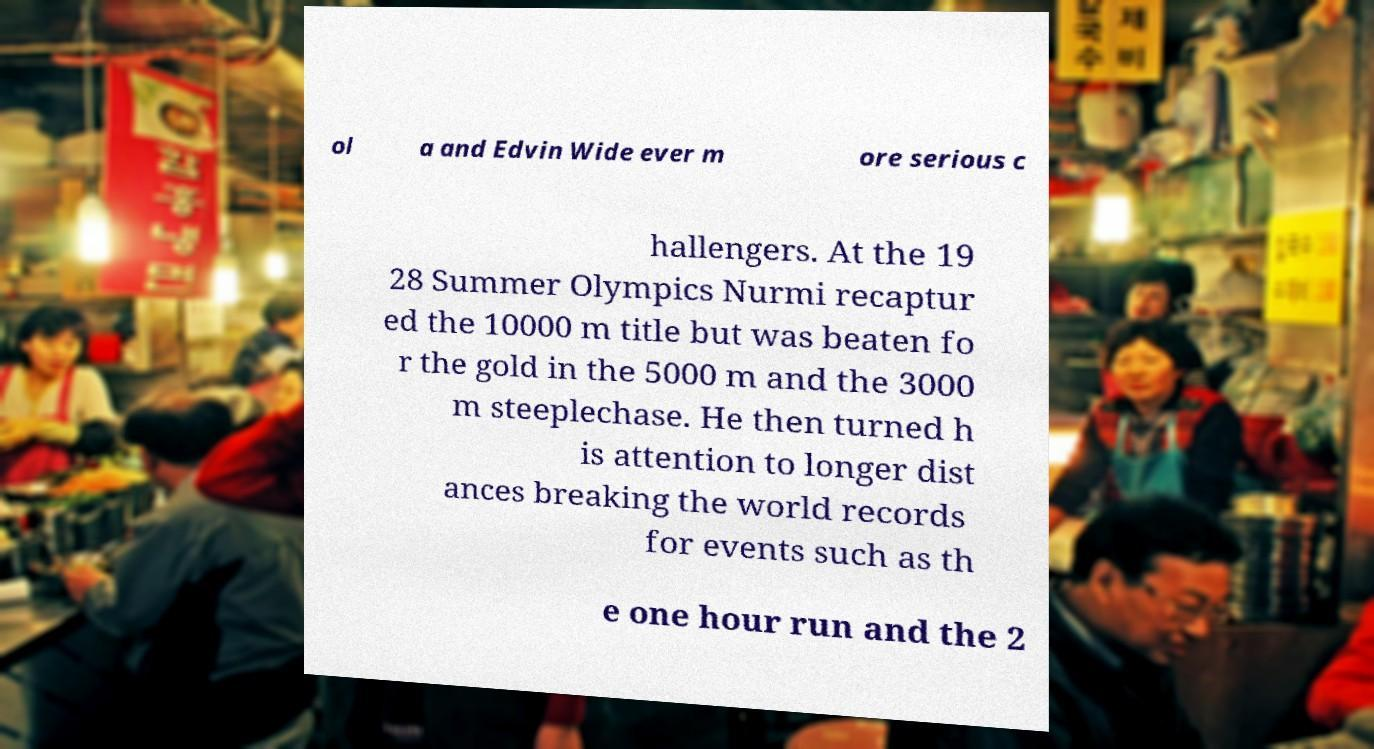What messages or text are displayed in this image? I need them in a readable, typed format. ol a and Edvin Wide ever m ore serious c hallengers. At the 19 28 Summer Olympics Nurmi recaptur ed the 10000 m title but was beaten fo r the gold in the 5000 m and the 3000 m steeplechase. He then turned h is attention to longer dist ances breaking the world records for events such as th e one hour run and the 2 